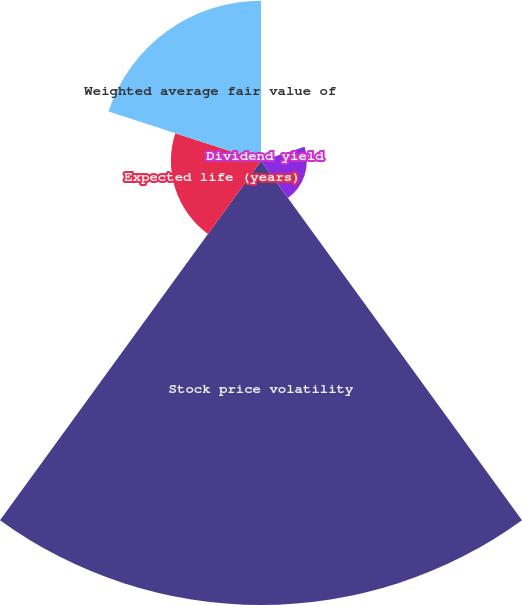<chart> <loc_0><loc_0><loc_500><loc_500><pie_chart><fcel>Dividend yield<fcel>Risk-free interest rate<fcel>Stock price volatility<fcel>Expected life (years)<fcel>Weighted average fair value of<nl><fcel>0.19%<fcel>6.18%<fcel>59.86%<fcel>12.15%<fcel>21.61%<nl></chart> 